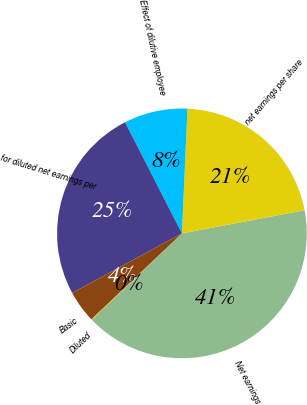Convert chart. <chart><loc_0><loc_0><loc_500><loc_500><pie_chart><fcel>Net earnings<fcel>net earnings per share<fcel>Effect of dilutive employee<fcel>for diluted net earnings per<fcel>Basic<fcel>Diluted<nl><fcel>40.79%<fcel>21.32%<fcel>8.24%<fcel>25.39%<fcel>4.17%<fcel>0.1%<nl></chart> 